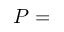Convert formula to latex. <formula><loc_0><loc_0><loc_500><loc_500>P =</formula> 